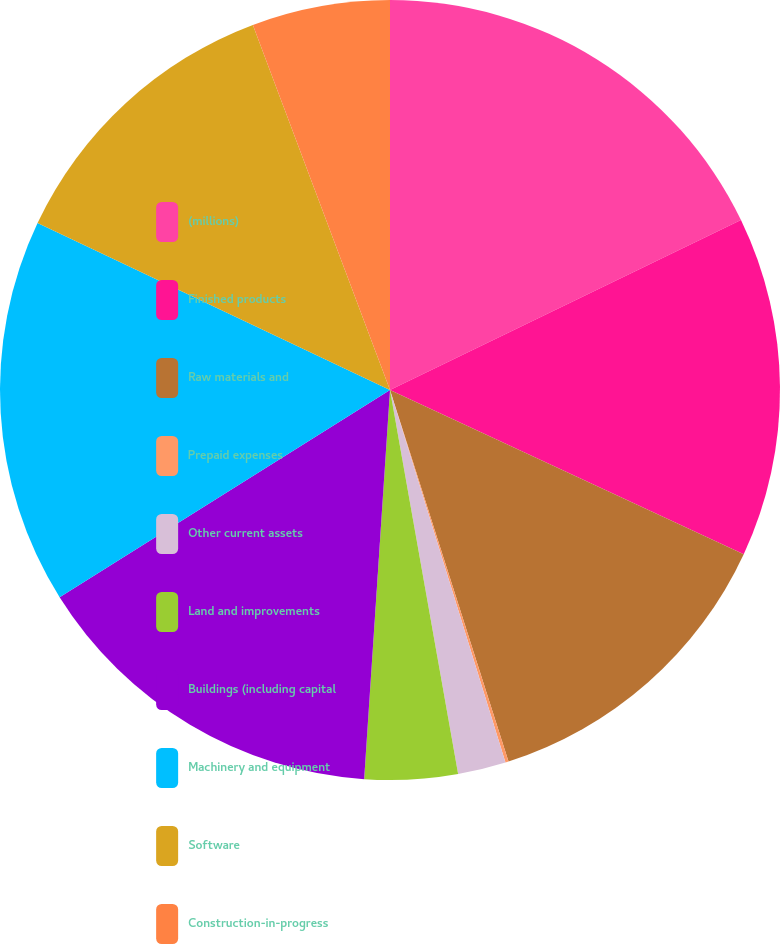<chart> <loc_0><loc_0><loc_500><loc_500><pie_chart><fcel>(millions)<fcel>Finished products<fcel>Raw materials and<fcel>Prepaid expenses<fcel>Other current assets<fcel>Land and improvements<fcel>Buildings (including capital<fcel>Machinery and equipment<fcel>Software<fcel>Construction-in-progress<nl><fcel>17.82%<fcel>14.1%<fcel>13.17%<fcel>0.13%<fcel>1.99%<fcel>3.85%<fcel>15.03%<fcel>15.96%<fcel>12.24%<fcel>5.72%<nl></chart> 